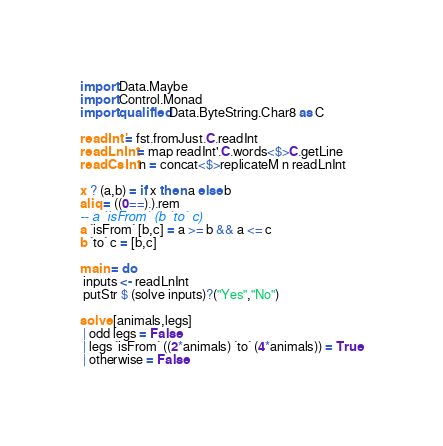<code> <loc_0><loc_0><loc_500><loc_500><_Haskell_>import Data.Maybe
import Control.Monad
import qualified Data.ByteString.Char8 as C

readInt' = fst.fromJust.C.readInt
readLnInt = map readInt'.C.words<$>C.getLine
readCsInt n = concat<$>replicateM n readLnInt

x ? (a,b) = if x then a else b
aliq = ((0==).).rem
-- a `isFrom` (b `to` c)
a `isFrom` [b,c] = a >= b && a <= c
b `to` c = [b,c]

main = do
 inputs <- readLnInt
 putStr $ (solve inputs)?("Yes","No")

solve [animals,legs]
 | odd legs = False
 | legs `isFrom` ((2*animals) `to` (4*animals)) = True
 | otherwise = False
</code> 